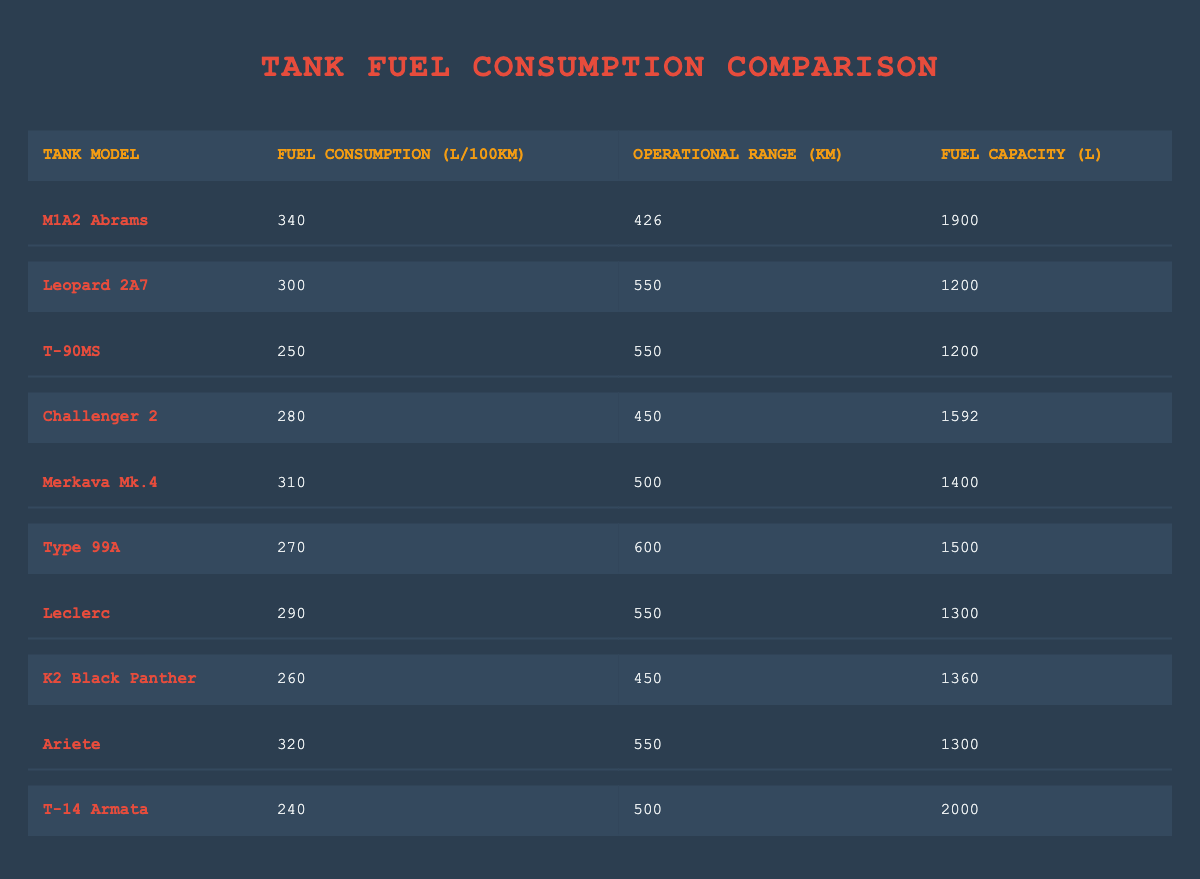What is the fuel consumption of the T-90MS? The fuel consumption of the T-90MS is listed in the second column of its respective row in the table. Looking at the data, it shows that the T-90MS has a fuel consumption of 250 L/100km.
Answer: 250 L/100km Which tank has the highest fuel capacity? To find which tank has the highest fuel capacity, we compare the values in the last column of each row. The T-14 Armata has a fuel capacity of 2000 liters, which is greater than all other tanks listed.
Answer: T-14 Armata What is the operational range of the Leopard 2A7? The operational range is found in the third column for the Leopard 2A7, which indicates that it can operate over 550 kilometers.
Answer: 550 km What is the average fuel consumption of the tanks listed? To calculate the average fuel consumption, we first sum all of the fuel consumption values (340 + 300 + 250 + 280 + 310 + 270 + 290 + 260 + 320 + 240) which equals 2,820 L/100km. There are 10 tank models, so divide the sum by 10, giving an average of 282 L/100km.
Answer: 282 L/100km Is the fuel consumption of the Challenger 2 lower than that of the K2 Black Panther? To answer this question, we compare the values in the second column for both tanks. The Challenger 2 consumes 280 L/100km, while the K2 Black Panther consumes 260 L/100km, confirming that the Challenger 2's fuel consumption is higher. Therefore, the statement is false.
Answer: No Which tank has the best fuel efficiency, meaning the lowest fuel consumption? To determine the tank with the best fuel efficiency, we look for the lowest value in the second column. The T-14 Armata has the lowest fuel consumption at 240 L/100km, making it the most fuel-efficient tank among those listed.
Answer: T-14 Armata How much greater is the fuel capacity of the M1A2 Abrams compared to the Type 99A? We take the fuel capacity values of both tanks from the last column: the M1A2 Abrams has a capacity of 1900 liters, and the Type 99A has 1500 liters. The difference is calculated as 1900 - 1500 = 400 liters, indicating that the M1A2 Abrams has a fuel capacity 400 liters greater than the Type 99A.
Answer: 400 liters Are there any tanks with a fuel consumption higher than 300 L/100km? We check the fuel consumption values in the second column to see if any model exceeds 300 L/100km. Both the M1A2 Abrams and Ariete are above this threshold, confirming the statement is true.
Answer: Yes 